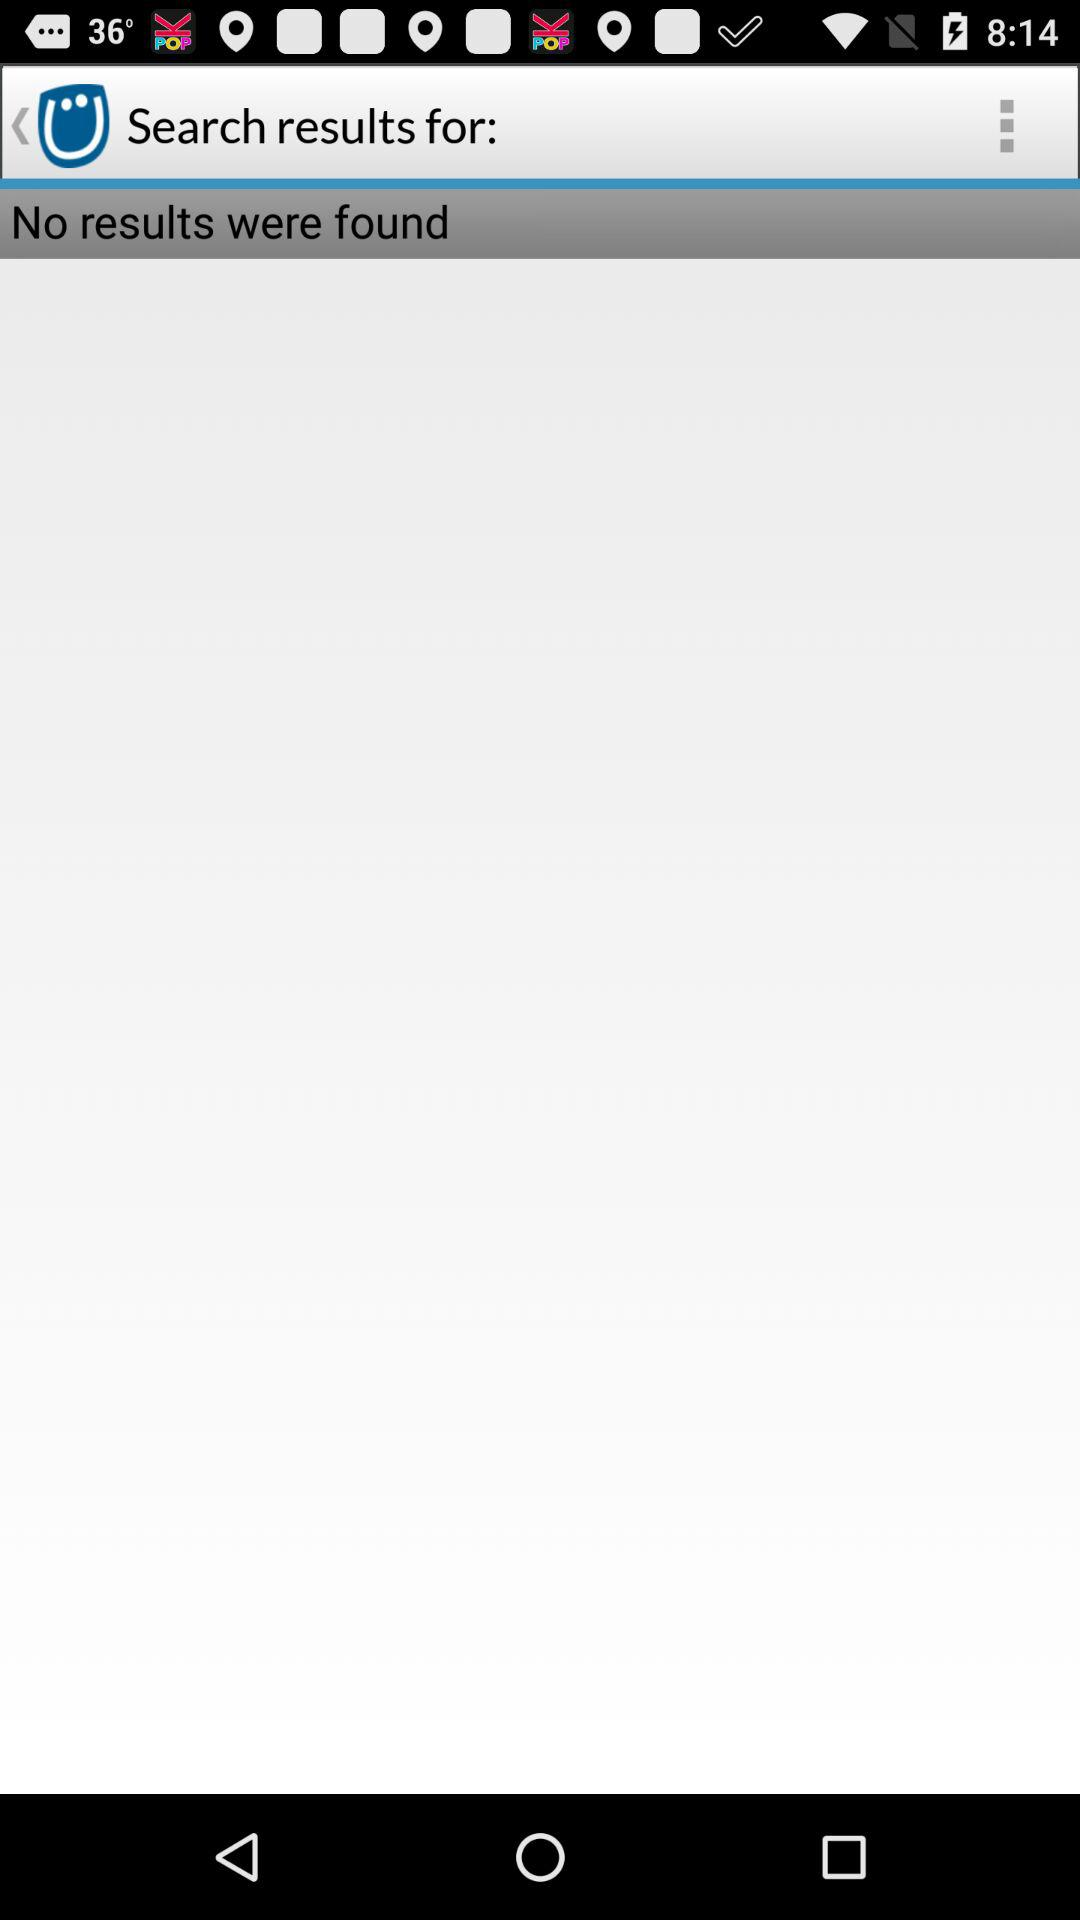How many results have been displayed? There is no result displayed. 